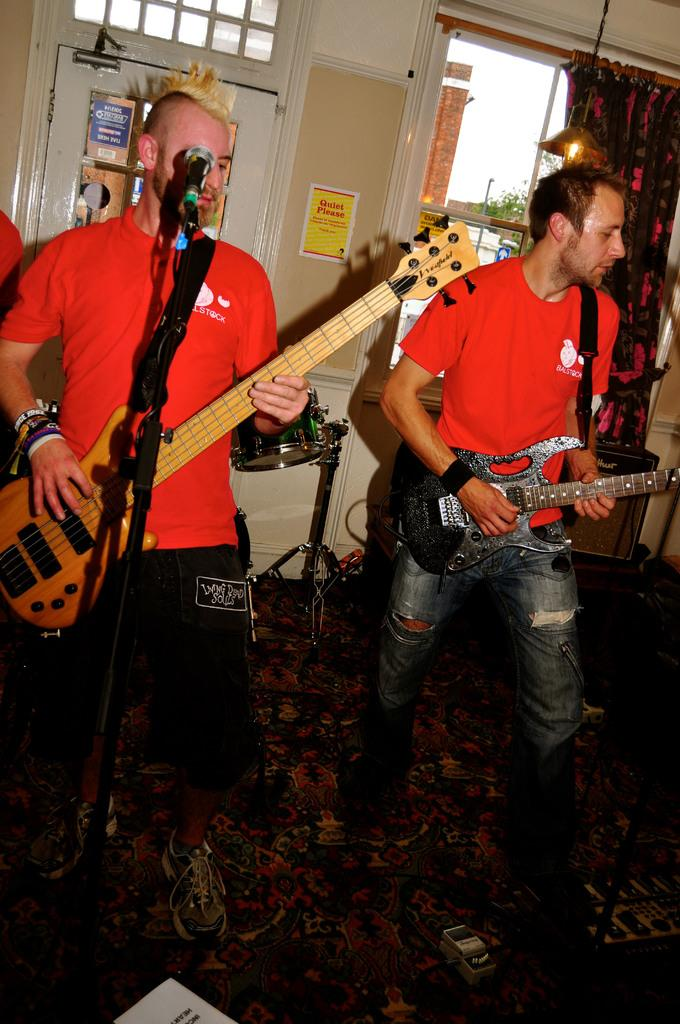How many people are in the room? There are two men in the room. What are the men wearing? Both men are wearing red T-shirts. What activity are the men engaged in? The men are playing guitar and singing. How is one of the men amplifying his voice? One of them is using a microphone. What is present at the entrance to the room? A curtain is hanging on the entrance. Can you tell me how many drains are visible in the room? There are no drains visible in the room; the image features two men playing guitar and singing. 